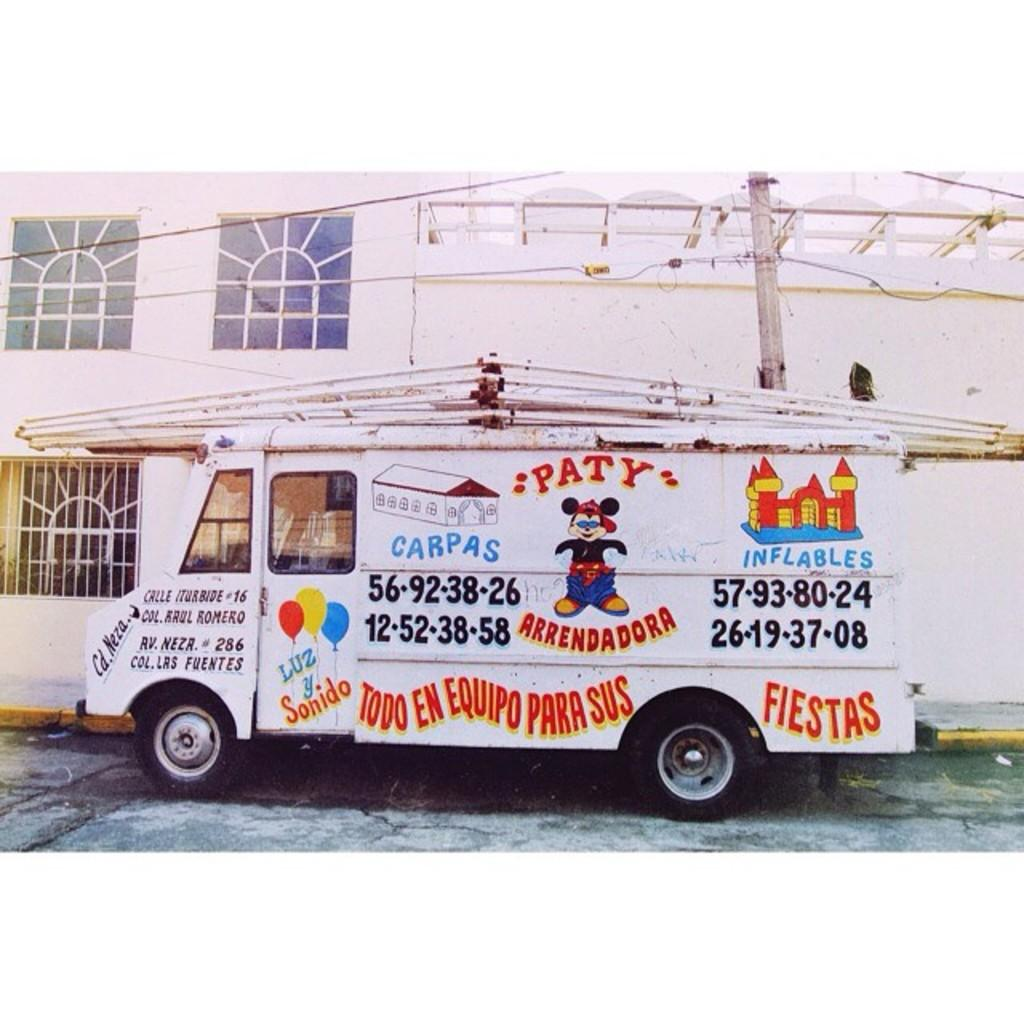<image>
Share a concise interpretation of the image provided. A white truck with a bouncy house and a phone number and words in a foreign language on it. 